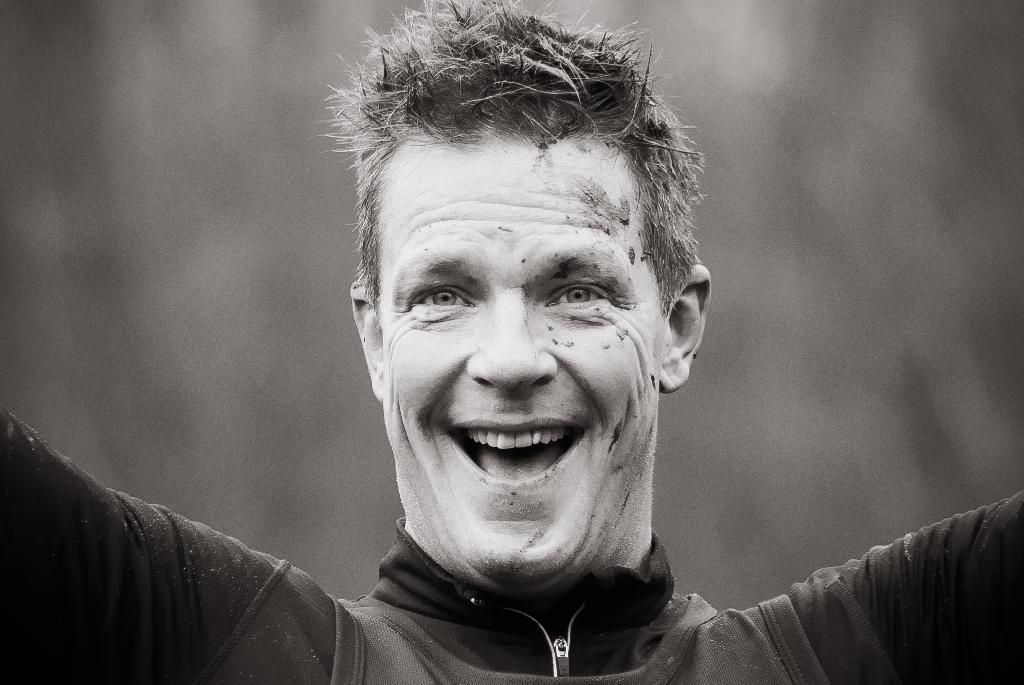How would you summarize this image in a sentence or two? In the picture I can see a man in the middle of the image. He is wearing a black color jacket and there is a smile on his face. 